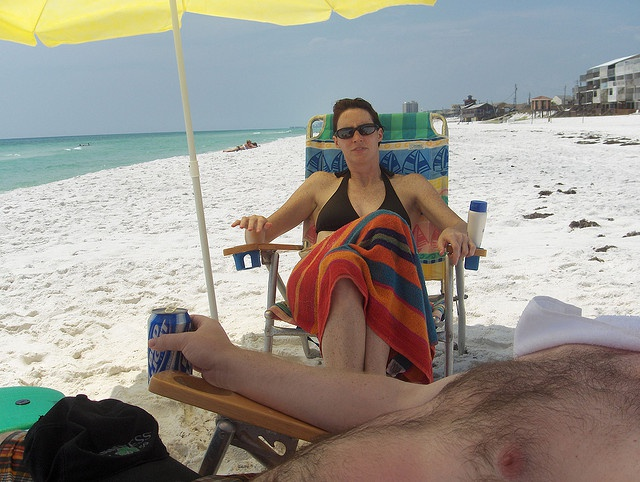Describe the objects in this image and their specific colors. I can see people in khaki, brown, gray, and maroon tones, people in khaki, maroon, gray, black, and brown tones, umbrella in khaki and darkgray tones, chair in khaki, gray, teal, and tan tones, and chair in khaki, black, maroon, and gray tones in this image. 